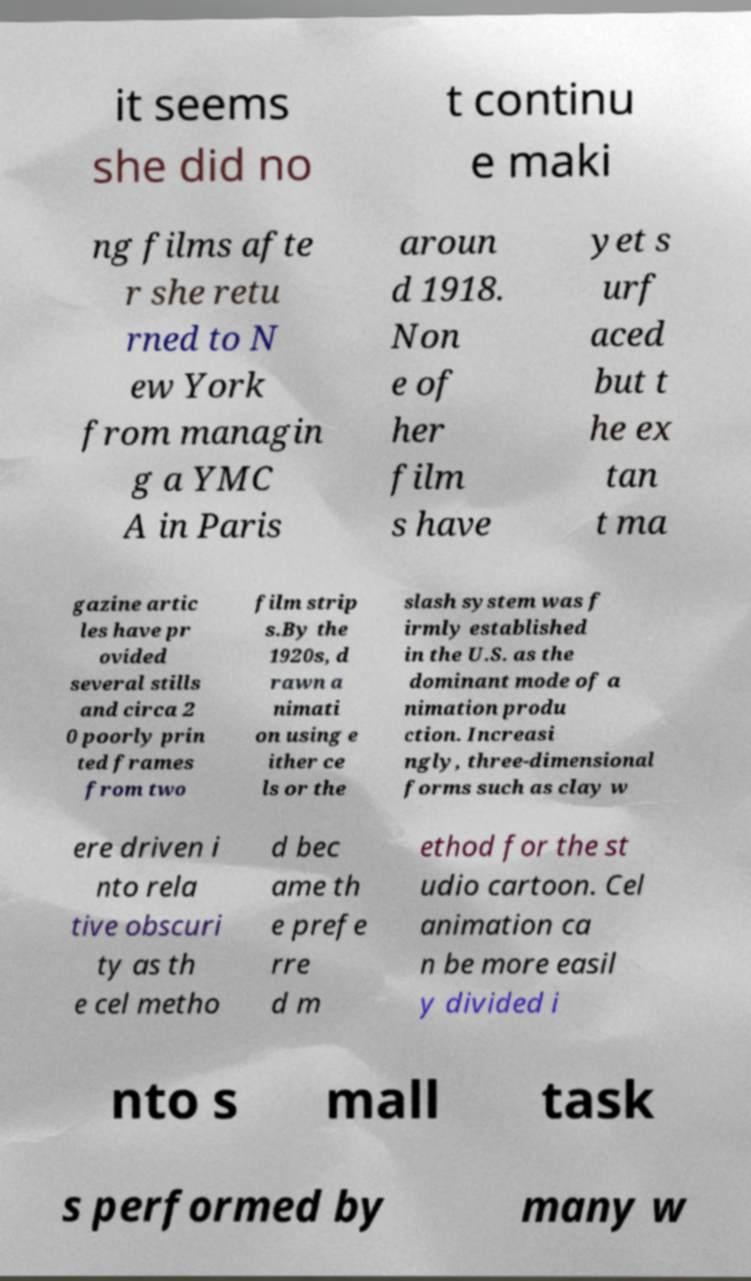Can you read and provide the text displayed in the image?This photo seems to have some interesting text. Can you extract and type it out for me? it seems she did no t continu e maki ng films afte r she retu rned to N ew York from managin g a YMC A in Paris aroun d 1918. Non e of her film s have yet s urf aced but t he ex tan t ma gazine artic les have pr ovided several stills and circa 2 0 poorly prin ted frames from two film strip s.By the 1920s, d rawn a nimati on using e ither ce ls or the slash system was f irmly established in the U.S. as the dominant mode of a nimation produ ction. Increasi ngly, three-dimensional forms such as clay w ere driven i nto rela tive obscuri ty as th e cel metho d bec ame th e prefe rre d m ethod for the st udio cartoon. Cel animation ca n be more easil y divided i nto s mall task s performed by many w 